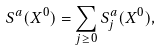Convert formula to latex. <formula><loc_0><loc_0><loc_500><loc_500>S ^ { a } ( X ^ { 0 } ) = \sum _ { j \geq 0 } S ^ { a } _ { j } ( X ^ { 0 } ) ,</formula> 